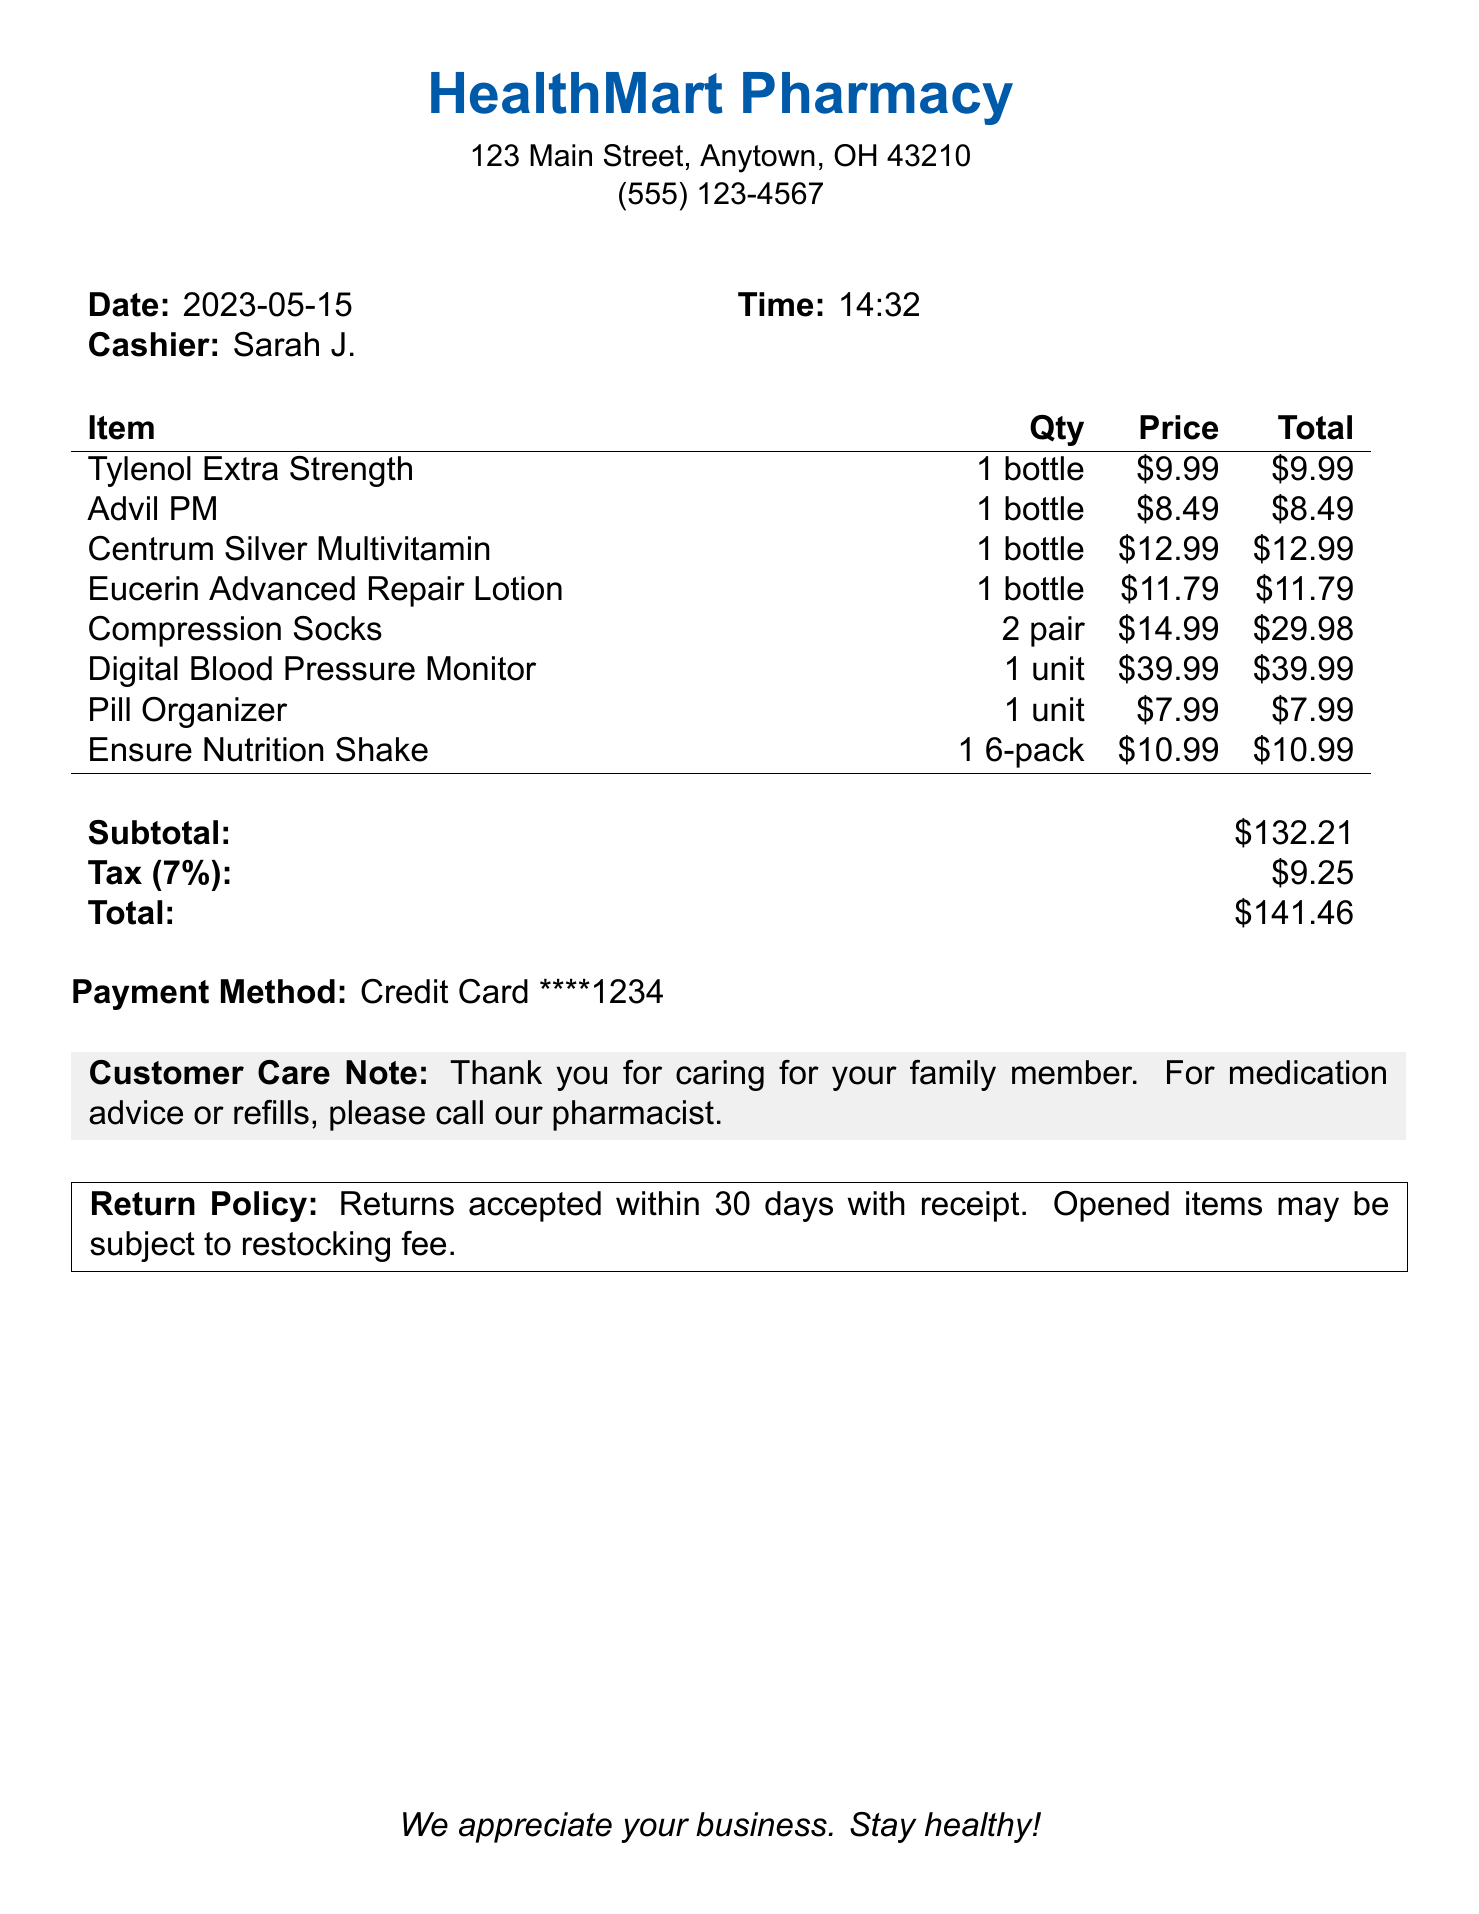What is the pharmacy's name? The pharmacy's name is indicated at the top of the receipt.
Answer: HealthMart Pharmacy What is the total cost of the items purchased? The total cost is displayed towards the end of the receipt.
Answer: $141.46 How many Compression Socks were bought? The quantity for Compression Socks is specified in the item list.
Answer: 2 pair Who was the cashier for this transaction? The cashier's name is mentioned in a section detailing the transaction.
Answer: Sarah J What is the tax amount charged? The tax amount is listed along with the subtotal and total at the bottom of the receipt.
Answer: $9.25 What payment method was used? The payment method is clearly stated at the bottom of the receipt.
Answer: Credit Card What is the date of the purchase? The date of the transaction is provided near the top of the receipt.
Answer: 2023-05-15 What item is specifically noted for nutrition? The item associated with nutrition is indicated in the list of purchased items.
Answer: Ensure Nutrition Shake What is the return policy? The return policy is detailed at the bottom of the receipt in a box.
Answer: Returns accepted within 30 days with receipt 